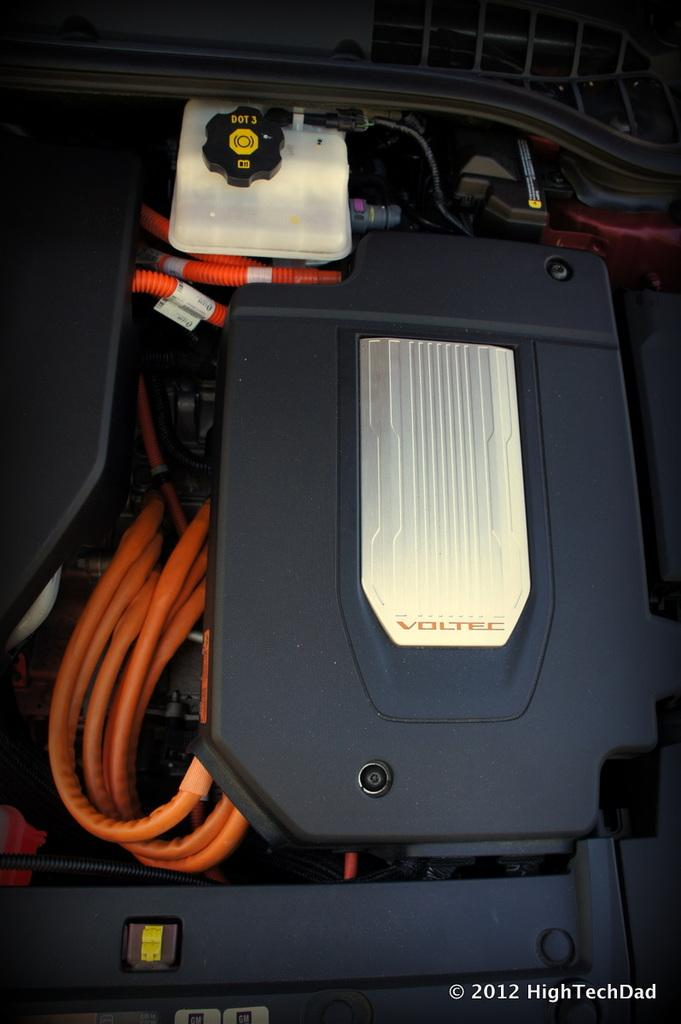What object is present in the image? There is a box in the image. Are there any additional elements associated with the box? Yes, there are wires associated with the box. How many curves can be seen on the heart in the image? There is no heart present in the image; it features a box and wires. How many sisters are visible interacting with the box in the image? There are no people, including sisters, visible interacting with the box in the image. 